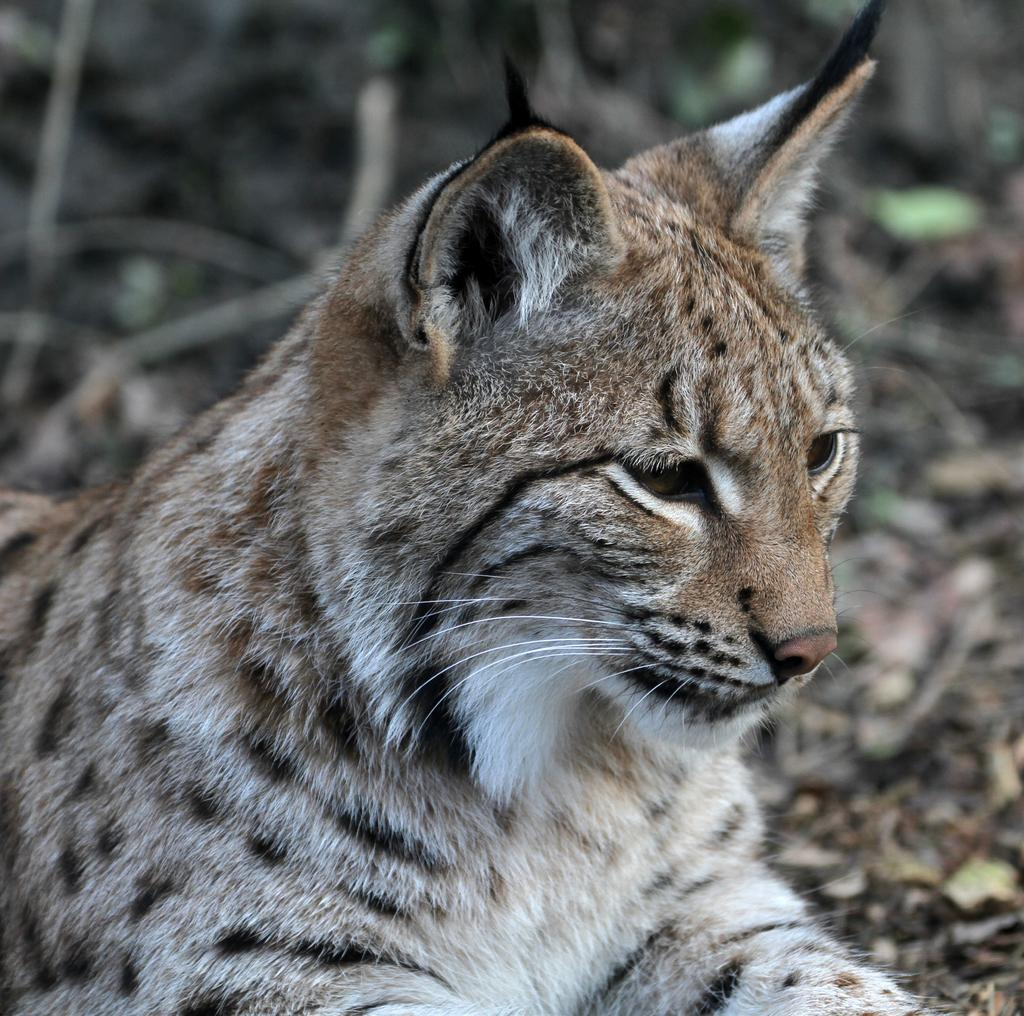What type of animal is in the picture? There is a bobcat in the picture. What can be seen on the ground in the picture? Dried leaves and twigs are visible in the picture. How would you describe the background of the image? The background of the image is blurred. What type of sugar is sprinkled on the bobcat in the picture? There is no sugar present in the image; it features a bobcat in a natural setting with dried leaves and twigs. 